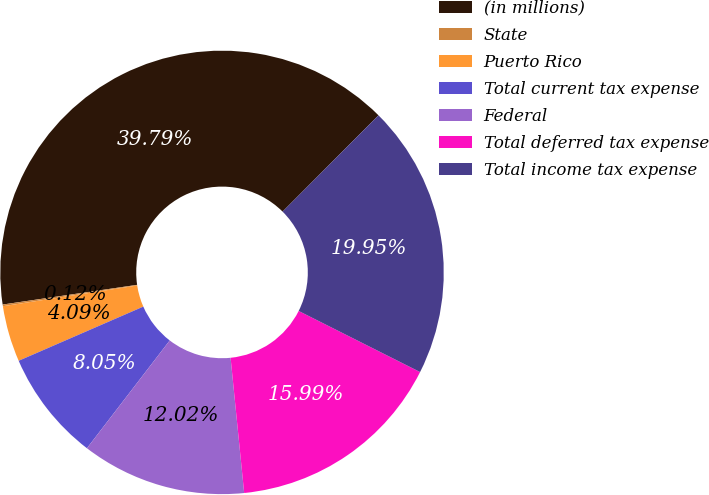Convert chart to OTSL. <chart><loc_0><loc_0><loc_500><loc_500><pie_chart><fcel>(in millions)<fcel>State<fcel>Puerto Rico<fcel>Total current tax expense<fcel>Federal<fcel>Total deferred tax expense<fcel>Total income tax expense<nl><fcel>39.79%<fcel>0.12%<fcel>4.09%<fcel>8.05%<fcel>12.02%<fcel>15.99%<fcel>19.95%<nl></chart> 